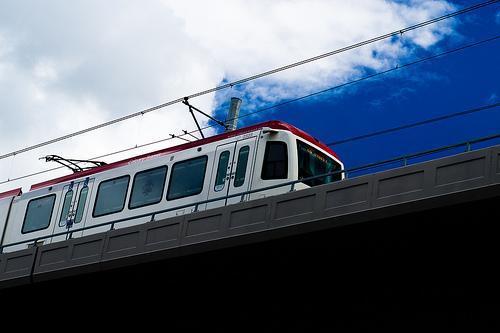How many buses are there?
Give a very brief answer. 1. 